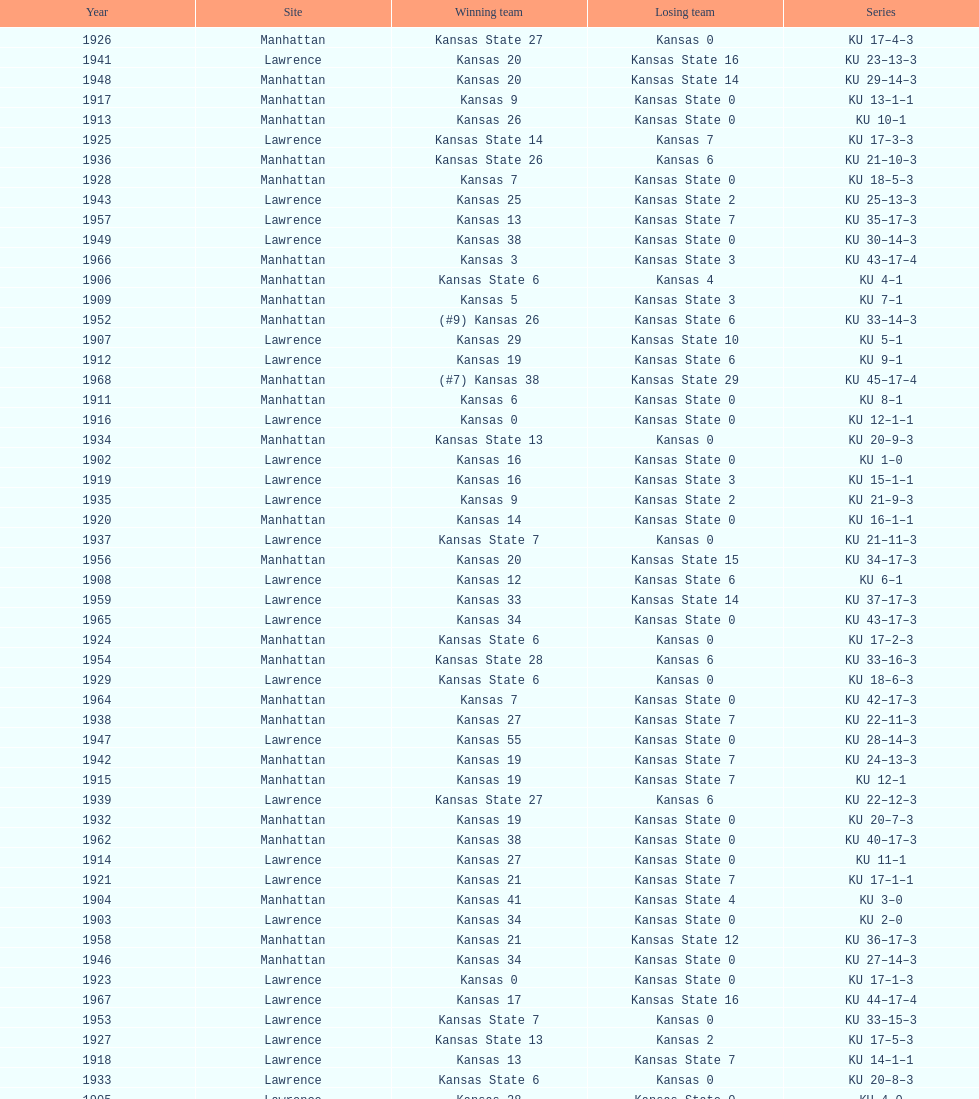How many times did kansas state not score at all against kansas from 1902-1968? 23. 